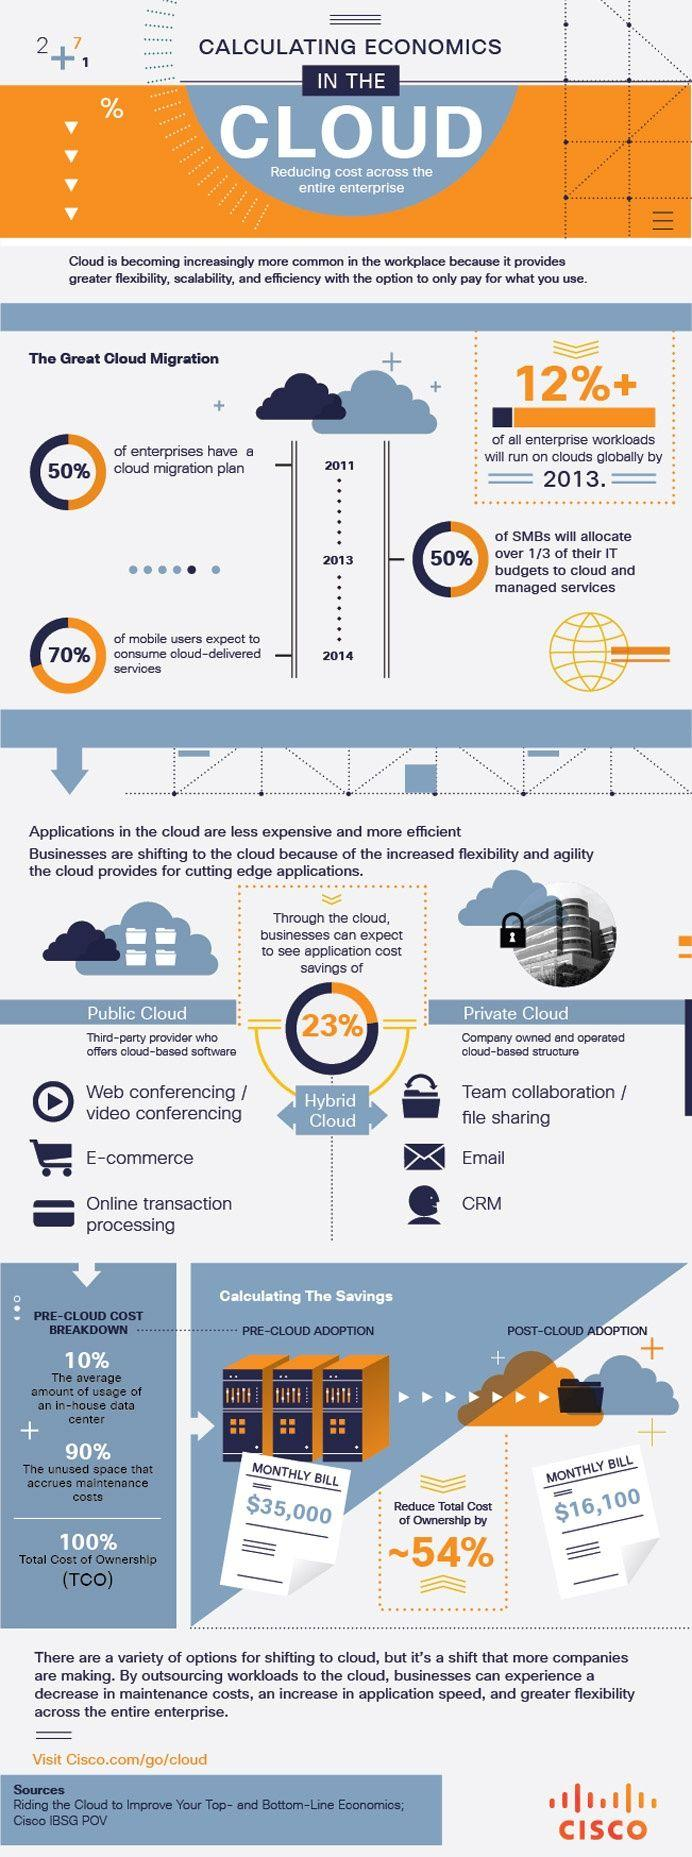List a handful of essential elements in this visual. The monthly bill for cloud adoption is estimated to be $16,100. A majority of businesses, or 50%, do not have a plan to migrate to the cloud. It is estimated that approximately 23% of IT costs can be saved by using cloud computing. 